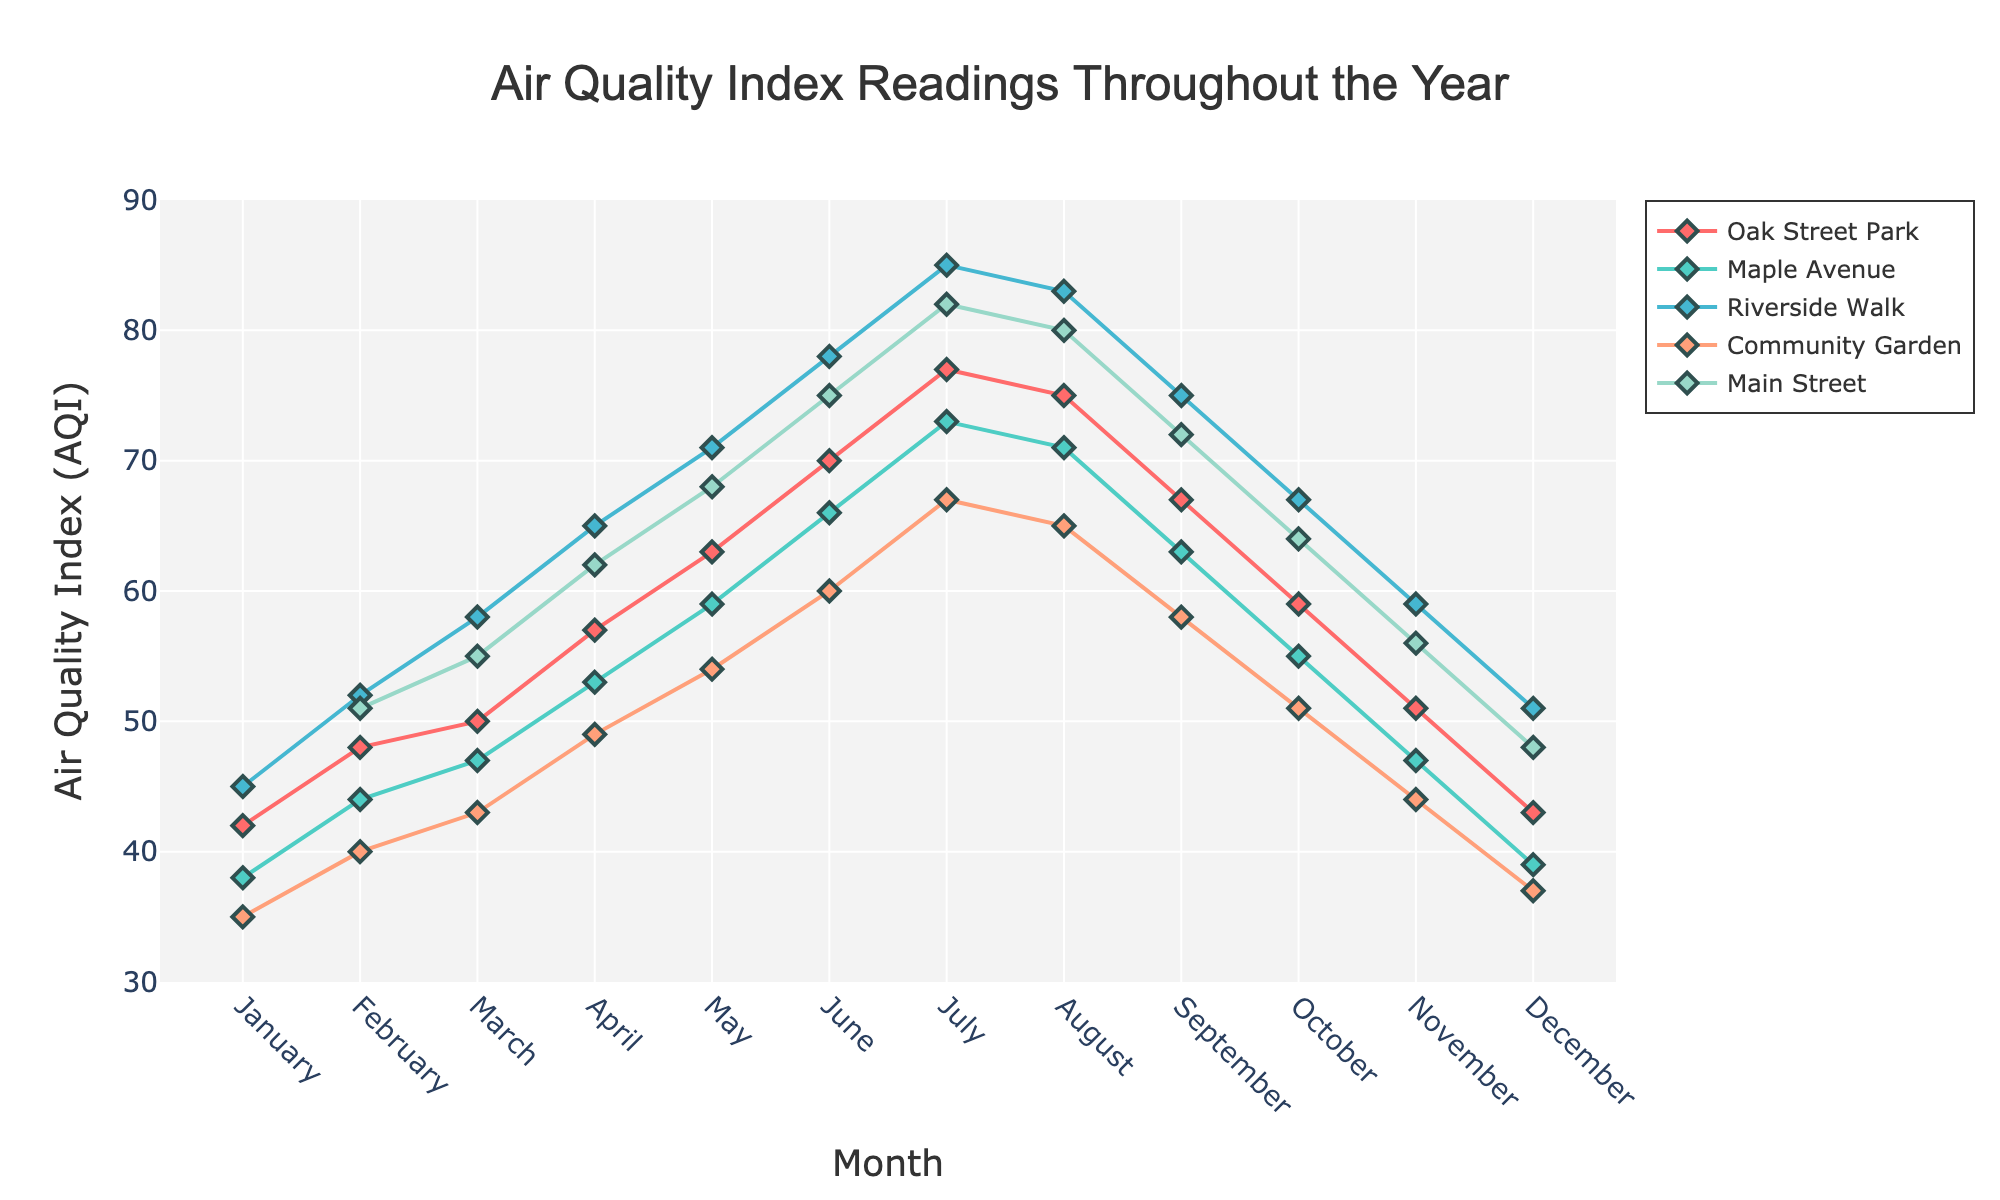What's the title of the plot? Look at the text at the top center of the plot where the title is usually placed. The title provided in the layout code is 'Air Quality Index Readings Throughout the Year'.
Answer: Air Quality Index Readings Throughout the Year Which location has the highest AQI value in July? Look for the month of July on the x-axis and identify the highest data point. According to the data, Riverside Walk has the highest AQI value of 85 in July.
Answer: Riverside Walk What's the difference between the AQI values of Oak Street Park and Community Garden in August? Find the data points for Oak Street Park and Community Garden in August. Oak Street Park has an AQI of 75, while Community Garden has an AQI of 65. The difference is 75 - 65.
Answer: 10 Which location consistently has the lowest AQI values throughout the year? Compare the AQI values for each location across all months. Community Garden generally appears to have the lowest AQI values throughout the year as indicated by being the lowest in most months.
Answer: Community Garden What is the trend of AQI values for Main Street from January to December? Examine the data points for Main Street from January to December. The AQI values generally increase from January (48) to a peak in July (82) then decrease towards December (48).
Answer: Mainly increasing then decreasing How much did the AQI for Maple Avenue change from January to June? Find the AQI values for Maple Avenue in January and June. The values are 38 and 66, respectively. The change is 66 - 38.
Answer: 28 In which month did Riverside Walk have the highest AQI value, and what is the value? Identify the peak value for Riverside Walk throughout the months. The highest AQI value for Riverside Walk is in July with a value of 85.
Answer: July, 85 Which location had the most significant increase in AQI from January to December? Compare the AQI values for each location in January and December. Main Street shows a significant increase from 42 in January to 48 in December, which is not as significant as Oak Street Park with a 37 increase (from 43 to 80) but still noticeable.
Answer: Main Street What is the average AQI value for Oak Street Park across the year? Sum the AQI values for Oak Street Park across all months and divide by the number of months. The sum is 548, dividing by 12 months.
Answer: 45.67 